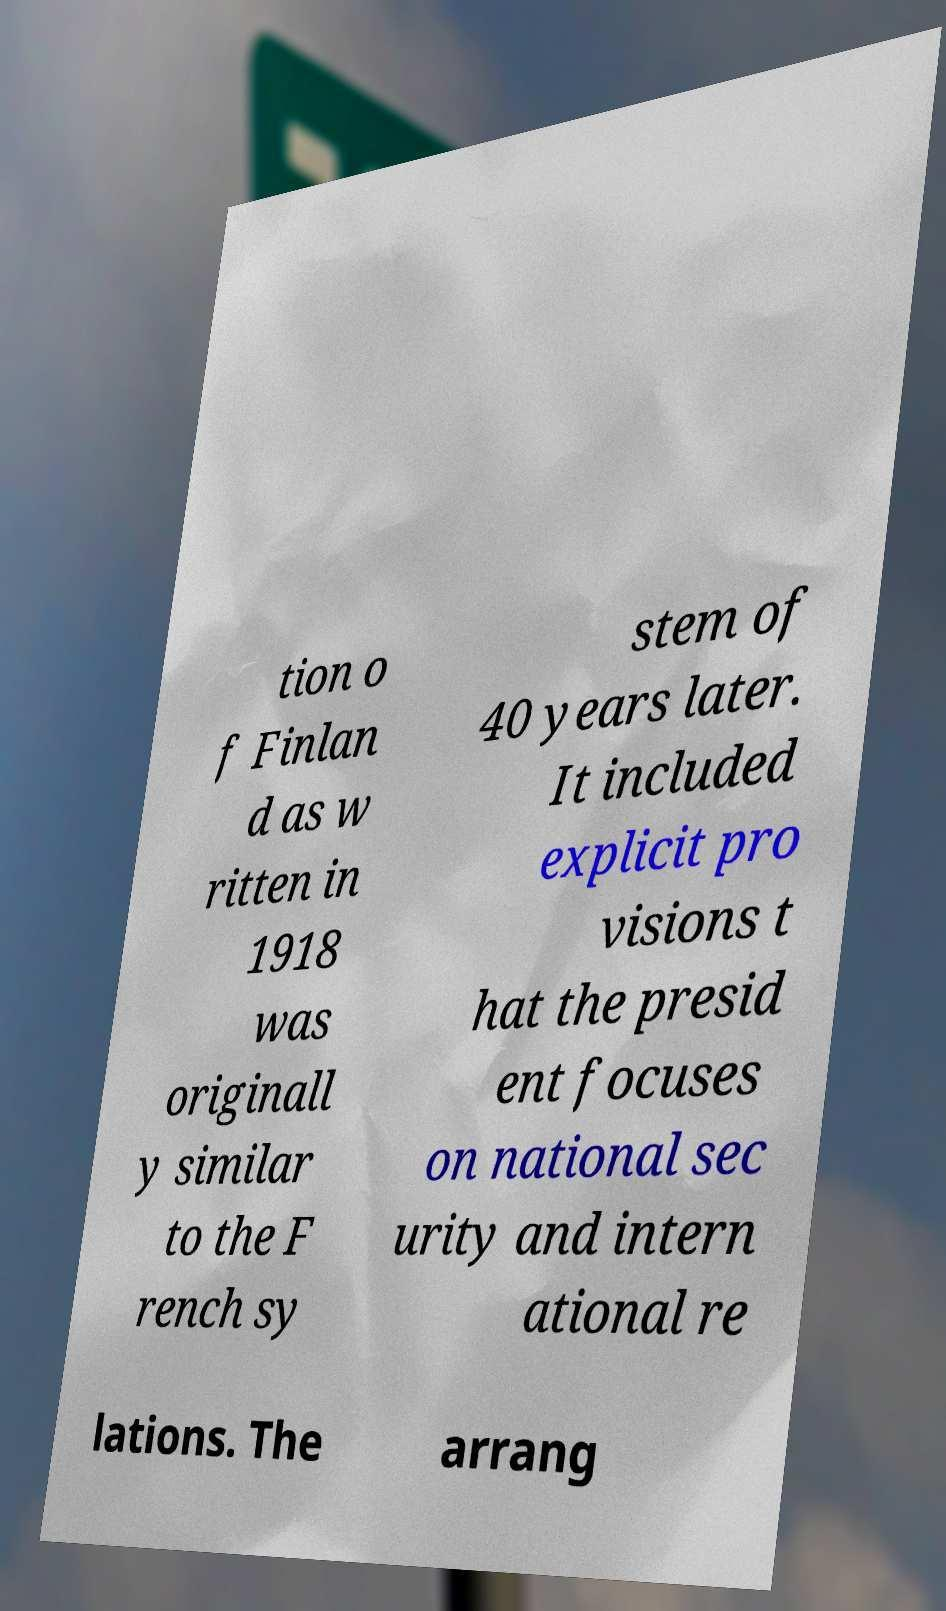I need the written content from this picture converted into text. Can you do that? tion o f Finlan d as w ritten in 1918 was originall y similar to the F rench sy stem of 40 years later. It included explicit pro visions t hat the presid ent focuses on national sec urity and intern ational re lations. The arrang 